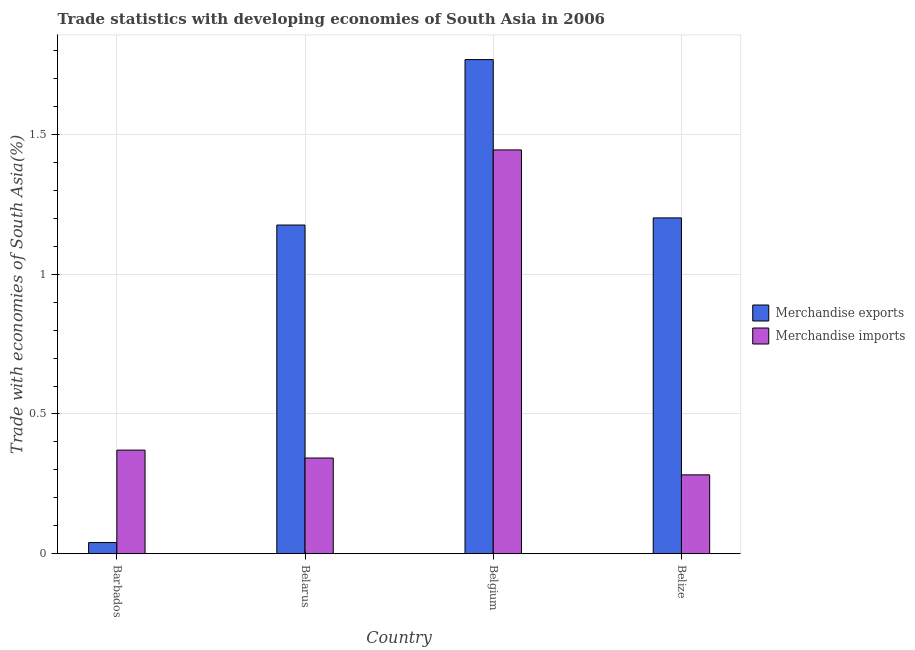Are the number of bars per tick equal to the number of legend labels?
Your response must be concise. Yes. Are the number of bars on each tick of the X-axis equal?
Give a very brief answer. Yes. How many bars are there on the 2nd tick from the left?
Make the answer very short. 2. What is the label of the 2nd group of bars from the left?
Make the answer very short. Belarus. What is the merchandise imports in Belarus?
Give a very brief answer. 0.34. Across all countries, what is the maximum merchandise imports?
Offer a terse response. 1.45. Across all countries, what is the minimum merchandise imports?
Offer a very short reply. 0.28. In which country was the merchandise exports maximum?
Provide a short and direct response. Belgium. In which country was the merchandise imports minimum?
Your answer should be compact. Belize. What is the total merchandise exports in the graph?
Provide a succinct answer. 4.19. What is the difference between the merchandise exports in Barbados and that in Belize?
Keep it short and to the point. -1.16. What is the difference between the merchandise exports in Belgium and the merchandise imports in Belize?
Your answer should be very brief. 1.49. What is the average merchandise exports per country?
Make the answer very short. 1.05. What is the difference between the merchandise exports and merchandise imports in Belarus?
Give a very brief answer. 0.83. What is the ratio of the merchandise imports in Belarus to that in Belize?
Give a very brief answer. 1.21. Is the merchandise exports in Belgium less than that in Belize?
Your answer should be very brief. No. Is the difference between the merchandise exports in Barbados and Belarus greater than the difference between the merchandise imports in Barbados and Belarus?
Ensure brevity in your answer.  No. What is the difference between the highest and the second highest merchandise imports?
Provide a succinct answer. 1.07. What is the difference between the highest and the lowest merchandise exports?
Provide a succinct answer. 1.73. In how many countries, is the merchandise exports greater than the average merchandise exports taken over all countries?
Give a very brief answer. 3. Is the sum of the merchandise imports in Barbados and Belize greater than the maximum merchandise exports across all countries?
Offer a terse response. No. What does the 1st bar from the left in Belgium represents?
Your answer should be very brief. Merchandise exports. What does the 1st bar from the right in Belgium represents?
Make the answer very short. Merchandise imports. How many countries are there in the graph?
Provide a succinct answer. 4. Are the values on the major ticks of Y-axis written in scientific E-notation?
Keep it short and to the point. No. Does the graph contain grids?
Provide a short and direct response. Yes. Where does the legend appear in the graph?
Ensure brevity in your answer.  Center right. What is the title of the graph?
Offer a very short reply. Trade statistics with developing economies of South Asia in 2006. Does "Urban Population" appear as one of the legend labels in the graph?
Provide a short and direct response. No. What is the label or title of the X-axis?
Provide a succinct answer. Country. What is the label or title of the Y-axis?
Offer a very short reply. Trade with economies of South Asia(%). What is the Trade with economies of South Asia(%) of Merchandise exports in Barbados?
Ensure brevity in your answer.  0.04. What is the Trade with economies of South Asia(%) in Merchandise imports in Barbados?
Give a very brief answer. 0.37. What is the Trade with economies of South Asia(%) of Merchandise exports in Belarus?
Your answer should be compact. 1.18. What is the Trade with economies of South Asia(%) in Merchandise imports in Belarus?
Provide a succinct answer. 0.34. What is the Trade with economies of South Asia(%) in Merchandise exports in Belgium?
Give a very brief answer. 1.77. What is the Trade with economies of South Asia(%) of Merchandise imports in Belgium?
Your answer should be very brief. 1.45. What is the Trade with economies of South Asia(%) of Merchandise exports in Belize?
Provide a succinct answer. 1.2. What is the Trade with economies of South Asia(%) in Merchandise imports in Belize?
Provide a succinct answer. 0.28. Across all countries, what is the maximum Trade with economies of South Asia(%) of Merchandise exports?
Keep it short and to the point. 1.77. Across all countries, what is the maximum Trade with economies of South Asia(%) in Merchandise imports?
Give a very brief answer. 1.45. Across all countries, what is the minimum Trade with economies of South Asia(%) of Merchandise exports?
Make the answer very short. 0.04. Across all countries, what is the minimum Trade with economies of South Asia(%) of Merchandise imports?
Give a very brief answer. 0.28. What is the total Trade with economies of South Asia(%) in Merchandise exports in the graph?
Keep it short and to the point. 4.19. What is the total Trade with economies of South Asia(%) in Merchandise imports in the graph?
Ensure brevity in your answer.  2.44. What is the difference between the Trade with economies of South Asia(%) in Merchandise exports in Barbados and that in Belarus?
Provide a succinct answer. -1.14. What is the difference between the Trade with economies of South Asia(%) of Merchandise imports in Barbados and that in Belarus?
Your response must be concise. 0.03. What is the difference between the Trade with economies of South Asia(%) of Merchandise exports in Barbados and that in Belgium?
Your response must be concise. -1.73. What is the difference between the Trade with economies of South Asia(%) in Merchandise imports in Barbados and that in Belgium?
Provide a short and direct response. -1.07. What is the difference between the Trade with economies of South Asia(%) in Merchandise exports in Barbados and that in Belize?
Keep it short and to the point. -1.16. What is the difference between the Trade with economies of South Asia(%) in Merchandise imports in Barbados and that in Belize?
Give a very brief answer. 0.09. What is the difference between the Trade with economies of South Asia(%) of Merchandise exports in Belarus and that in Belgium?
Provide a succinct answer. -0.59. What is the difference between the Trade with economies of South Asia(%) in Merchandise imports in Belarus and that in Belgium?
Your answer should be very brief. -1.1. What is the difference between the Trade with economies of South Asia(%) in Merchandise exports in Belarus and that in Belize?
Give a very brief answer. -0.03. What is the difference between the Trade with economies of South Asia(%) of Merchandise imports in Belarus and that in Belize?
Your answer should be compact. 0.06. What is the difference between the Trade with economies of South Asia(%) of Merchandise exports in Belgium and that in Belize?
Give a very brief answer. 0.57. What is the difference between the Trade with economies of South Asia(%) in Merchandise imports in Belgium and that in Belize?
Provide a succinct answer. 1.16. What is the difference between the Trade with economies of South Asia(%) of Merchandise exports in Barbados and the Trade with economies of South Asia(%) of Merchandise imports in Belarus?
Provide a succinct answer. -0.3. What is the difference between the Trade with economies of South Asia(%) of Merchandise exports in Barbados and the Trade with economies of South Asia(%) of Merchandise imports in Belgium?
Make the answer very short. -1.41. What is the difference between the Trade with economies of South Asia(%) in Merchandise exports in Barbados and the Trade with economies of South Asia(%) in Merchandise imports in Belize?
Give a very brief answer. -0.24. What is the difference between the Trade with economies of South Asia(%) of Merchandise exports in Belarus and the Trade with economies of South Asia(%) of Merchandise imports in Belgium?
Provide a succinct answer. -0.27. What is the difference between the Trade with economies of South Asia(%) in Merchandise exports in Belarus and the Trade with economies of South Asia(%) in Merchandise imports in Belize?
Offer a terse response. 0.89. What is the difference between the Trade with economies of South Asia(%) of Merchandise exports in Belgium and the Trade with economies of South Asia(%) of Merchandise imports in Belize?
Your response must be concise. 1.49. What is the average Trade with economies of South Asia(%) of Merchandise exports per country?
Your response must be concise. 1.05. What is the average Trade with economies of South Asia(%) of Merchandise imports per country?
Make the answer very short. 0.61. What is the difference between the Trade with economies of South Asia(%) in Merchandise exports and Trade with economies of South Asia(%) in Merchandise imports in Barbados?
Offer a terse response. -0.33. What is the difference between the Trade with economies of South Asia(%) of Merchandise exports and Trade with economies of South Asia(%) of Merchandise imports in Belarus?
Provide a succinct answer. 0.83. What is the difference between the Trade with economies of South Asia(%) in Merchandise exports and Trade with economies of South Asia(%) in Merchandise imports in Belgium?
Provide a succinct answer. 0.32. What is the difference between the Trade with economies of South Asia(%) in Merchandise exports and Trade with economies of South Asia(%) in Merchandise imports in Belize?
Your answer should be very brief. 0.92. What is the ratio of the Trade with economies of South Asia(%) of Merchandise exports in Barbados to that in Belarus?
Your answer should be compact. 0.03. What is the ratio of the Trade with economies of South Asia(%) of Merchandise imports in Barbados to that in Belarus?
Offer a very short reply. 1.08. What is the ratio of the Trade with economies of South Asia(%) of Merchandise exports in Barbados to that in Belgium?
Your response must be concise. 0.02. What is the ratio of the Trade with economies of South Asia(%) of Merchandise imports in Barbados to that in Belgium?
Give a very brief answer. 0.26. What is the ratio of the Trade with economies of South Asia(%) in Merchandise exports in Barbados to that in Belize?
Make the answer very short. 0.03. What is the ratio of the Trade with economies of South Asia(%) in Merchandise imports in Barbados to that in Belize?
Provide a succinct answer. 1.31. What is the ratio of the Trade with economies of South Asia(%) in Merchandise exports in Belarus to that in Belgium?
Give a very brief answer. 0.67. What is the ratio of the Trade with economies of South Asia(%) of Merchandise imports in Belarus to that in Belgium?
Your answer should be very brief. 0.24. What is the ratio of the Trade with economies of South Asia(%) in Merchandise exports in Belarus to that in Belize?
Your response must be concise. 0.98. What is the ratio of the Trade with economies of South Asia(%) in Merchandise imports in Belarus to that in Belize?
Give a very brief answer. 1.21. What is the ratio of the Trade with economies of South Asia(%) of Merchandise exports in Belgium to that in Belize?
Offer a terse response. 1.47. What is the ratio of the Trade with economies of South Asia(%) of Merchandise imports in Belgium to that in Belize?
Provide a short and direct response. 5.12. What is the difference between the highest and the second highest Trade with economies of South Asia(%) of Merchandise exports?
Your answer should be compact. 0.57. What is the difference between the highest and the second highest Trade with economies of South Asia(%) in Merchandise imports?
Provide a short and direct response. 1.07. What is the difference between the highest and the lowest Trade with economies of South Asia(%) in Merchandise exports?
Provide a short and direct response. 1.73. What is the difference between the highest and the lowest Trade with economies of South Asia(%) of Merchandise imports?
Your answer should be compact. 1.16. 